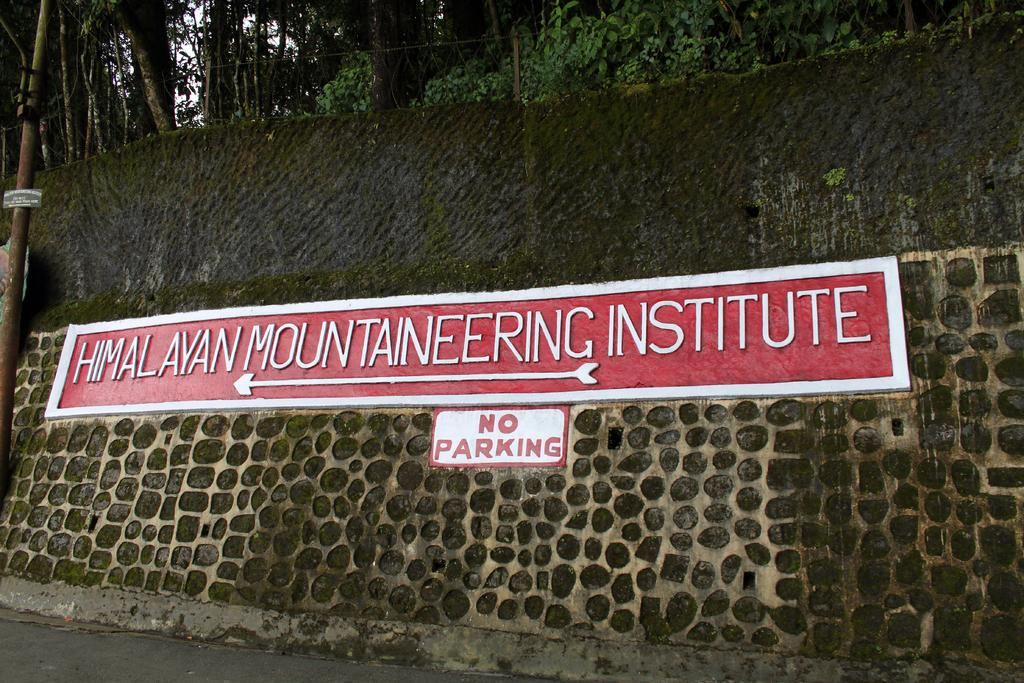What is present on the wall in the image? There is text on the wall in the image. What can be seen on the left side of the image? There is a pole on the left side of the image. What is visible in the background of the image? There are trees and plants on the ground in the background of the image. What type of cup is being used to serve the pizzas in the image? There are no cups or pizzas present in the image. What is your opinion on the text written on the wall in the image? The conversation does not include any opinions, as it is focused on providing factual information about the image. 